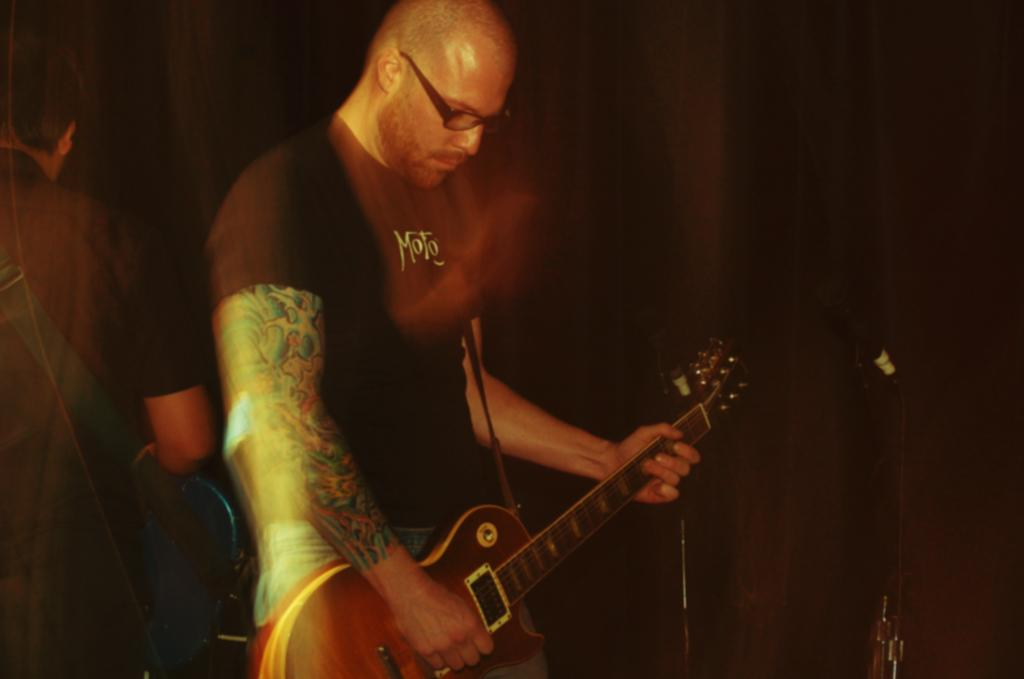What is the main activity being performed by the first man in the image? The first man is standing and playing guitar in the image. Is there anyone else in the image besides the first man? Yes, there is another man standing on the first man's back in the image. What is the second man holding in his hand? The second man is holding a guitar in his hand. What force is being applied to the first man's back by the second man in the image? There is no mention of force being applied in the image; the second man is simply standing on the first man's back. Where is this scene taking place, such as a park or a street? The location of the scene is not mentioned in the image, so it cannot be determined. 